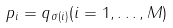Convert formula to latex. <formula><loc_0><loc_0><loc_500><loc_500>p _ { i } = q _ { \sigma ( i ) } ( i = 1 , \dots , M )</formula> 